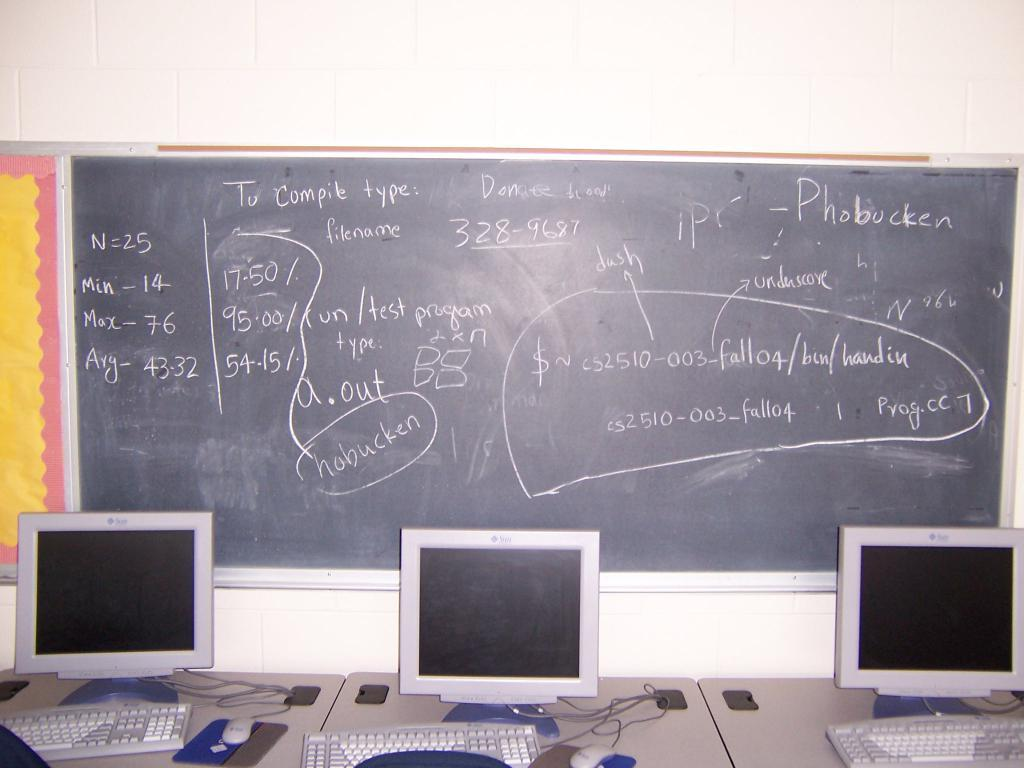Provide a one-sentence caption for the provided image. A chalk board displays instructions to compile a computer program. 